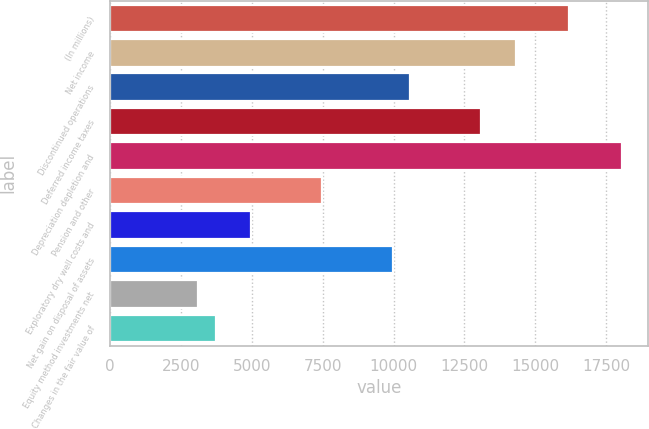<chart> <loc_0><loc_0><loc_500><loc_500><bar_chart><fcel>(In millions)<fcel>Net income<fcel>Discontinued operations<fcel>Deferred income taxes<fcel>Depreciation depletion and<fcel>Pension and other<fcel>Exploratory dry well costs and<fcel>Net gain on disposal of assets<fcel>Equity method investments net<fcel>Changes in the fair value of<nl><fcel>16194.2<fcel>14326.1<fcel>10589.9<fcel>13080.7<fcel>18062.3<fcel>7476.4<fcel>4985.6<fcel>9967.2<fcel>3117.5<fcel>3740.2<nl></chart> 